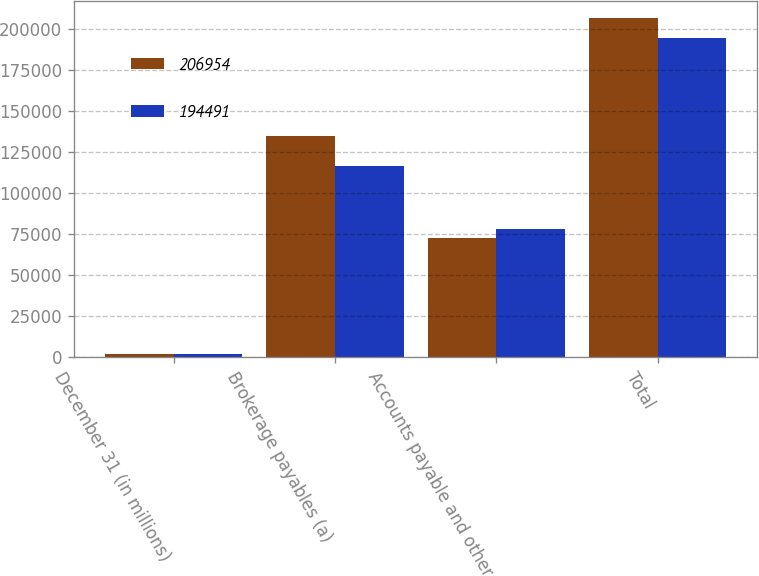<chart> <loc_0><loc_0><loc_500><loc_500><stacked_bar_chart><ecel><fcel>December 31 (in millions)<fcel>Brokerage payables (a)<fcel>Accounts payable and other<fcel>Total<nl><fcel>206954<fcel>2014<fcel>134467<fcel>72487<fcel>206954<nl><fcel>194491<fcel>2013<fcel>116391<fcel>78100<fcel>194491<nl></chart> 